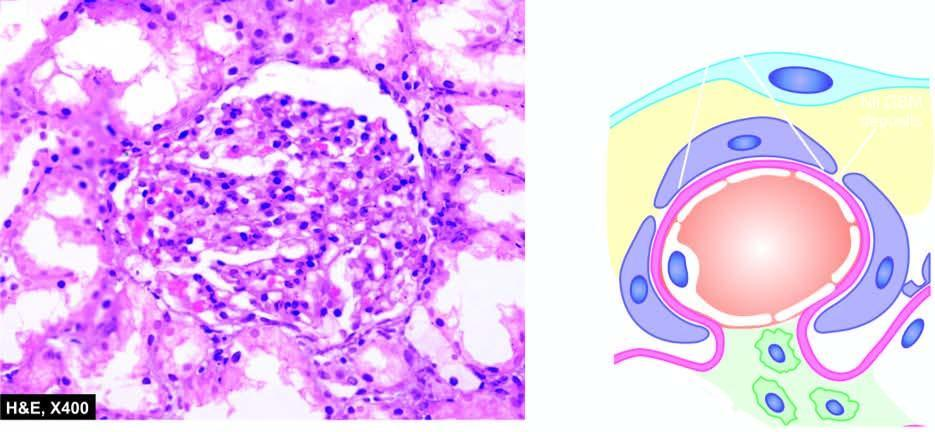what are there in the figure?
Answer the question using a single word or phrase. No deposits 